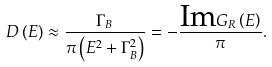Convert formula to latex. <formula><loc_0><loc_0><loc_500><loc_500>D \left ( E \right ) \approx \frac { \Gamma _ { B } } { \pi \left ( E ^ { 2 } + \Gamma _ { B } ^ { 2 } \right ) } = - \frac { \text {Im} G _ { R } \left ( E \right ) } { \pi } .</formula> 